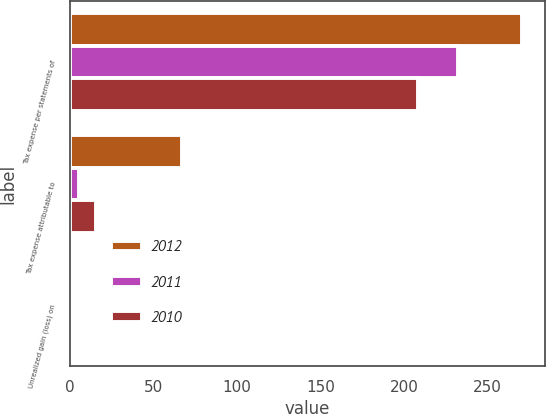<chart> <loc_0><loc_0><loc_500><loc_500><stacked_bar_chart><ecel><fcel>Tax expense per statements of<fcel>Tax expense attributable to<fcel>Unrealized gain (loss) on<nl><fcel>2012<fcel>270.9<fcel>67.4<fcel>2.1<nl><fcel>2011<fcel>232.4<fcel>5.8<fcel>1.5<nl><fcel>2010<fcel>208.4<fcel>15.5<fcel>1.9<nl></chart> 